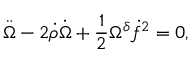Convert formula to latex. <formula><loc_0><loc_0><loc_500><loc_500>\ddot { \Omega } - 2 \dot { \rho } \dot { \Omega } + \frac { 1 } { 2 } \Omega ^ { \delta } \dot { f } ^ { 2 } = 0 ,</formula> 